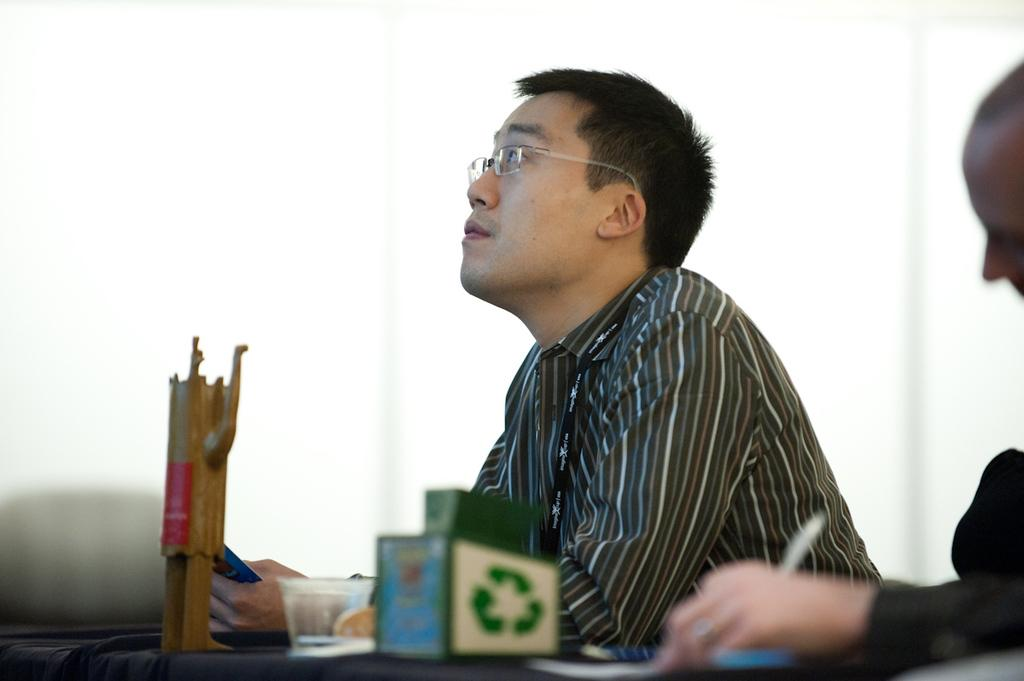What is the person in the image wearing? The person is wearing a shirt in the image. What is the person doing in the image? The person is sitting before a table in the image. What objects can be seen on the table? There is a cup, a box, and a wooden stand on the table in the image. What accessory is the person wearing? The person is wearing spectacles in the image. Can you describe the person on the right side of the image? The person on the right side of the image is holding a pen. What yard tool is the person using to stop the pen from rolling off the table? There is no yard tool present in the image, and the person is not using any tool to stop the pen from rolling off the table. 